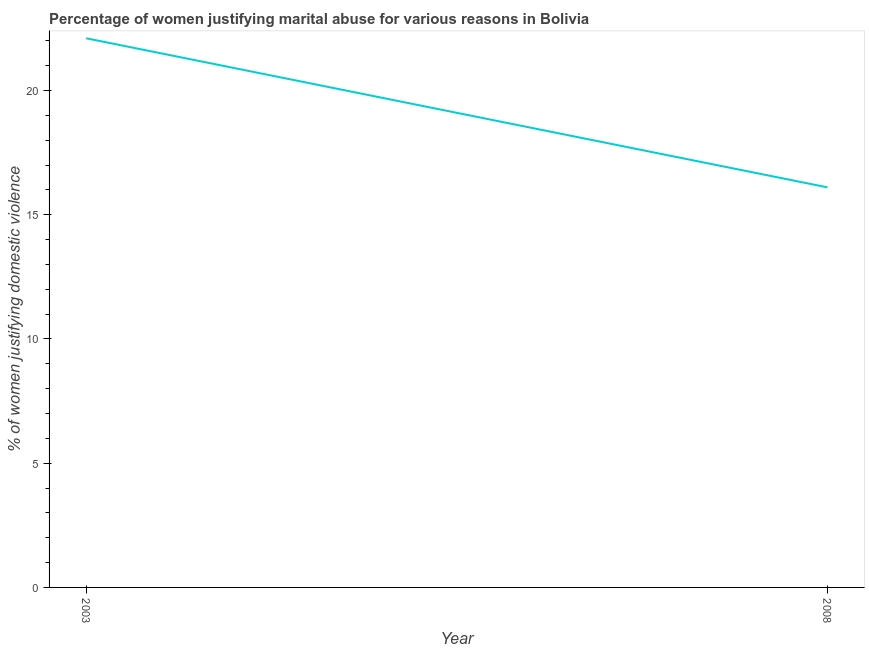Across all years, what is the maximum percentage of women justifying marital abuse?
Your response must be concise. 22.1. Across all years, what is the minimum percentage of women justifying marital abuse?
Offer a terse response. 16.1. In which year was the percentage of women justifying marital abuse minimum?
Provide a succinct answer. 2008. What is the sum of the percentage of women justifying marital abuse?
Your answer should be compact. 38.2. What is the average percentage of women justifying marital abuse per year?
Ensure brevity in your answer.  19.1. What is the median percentage of women justifying marital abuse?
Keep it short and to the point. 19.1. Do a majority of the years between 2003 and 2008 (inclusive) have percentage of women justifying marital abuse greater than 3 %?
Ensure brevity in your answer.  Yes. What is the ratio of the percentage of women justifying marital abuse in 2003 to that in 2008?
Your response must be concise. 1.37. Is the percentage of women justifying marital abuse in 2003 less than that in 2008?
Make the answer very short. No. Does the percentage of women justifying marital abuse monotonically increase over the years?
Provide a succinct answer. No. How many lines are there?
Keep it short and to the point. 1. What is the difference between two consecutive major ticks on the Y-axis?
Offer a terse response. 5. Does the graph contain any zero values?
Your answer should be compact. No. Does the graph contain grids?
Offer a terse response. No. What is the title of the graph?
Provide a short and direct response. Percentage of women justifying marital abuse for various reasons in Bolivia. What is the label or title of the Y-axis?
Your answer should be very brief. % of women justifying domestic violence. What is the % of women justifying domestic violence of 2003?
Provide a short and direct response. 22.1. What is the % of women justifying domestic violence of 2008?
Offer a terse response. 16.1. What is the ratio of the % of women justifying domestic violence in 2003 to that in 2008?
Provide a short and direct response. 1.37. 